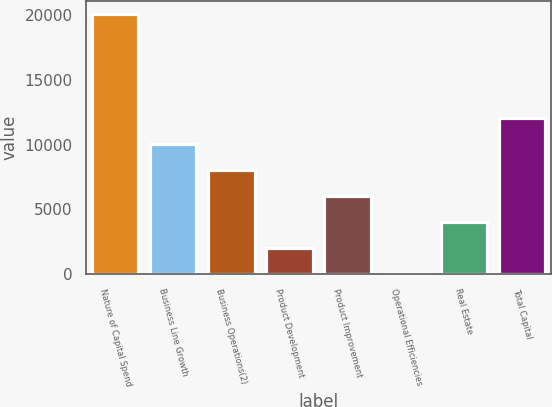Convert chart to OTSL. <chart><loc_0><loc_0><loc_500><loc_500><bar_chart><fcel>Nature of Capital Spend<fcel>Business Line Growth<fcel>Business Operations(2)<fcel>Product Development<fcel>Product Improvement<fcel>Operational Efficiencies<fcel>Real Estate<fcel>Total Capital<nl><fcel>20103<fcel>10051.6<fcel>8041.38<fcel>2010.57<fcel>6031.11<fcel>0.3<fcel>4020.84<fcel>12061.9<nl></chart> 